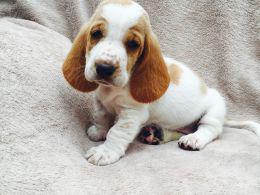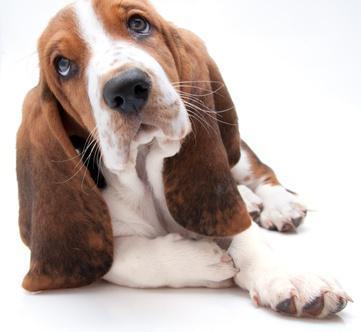The first image is the image on the left, the second image is the image on the right. Analyze the images presented: Is the assertion "The right image shows a single dog sitting." valid? Answer yes or no. No. The first image is the image on the left, the second image is the image on the right. Considering the images on both sides, is "One dog is reclining and one is sitting, and there are only two animals in total." valid? Answer yes or no. Yes. 